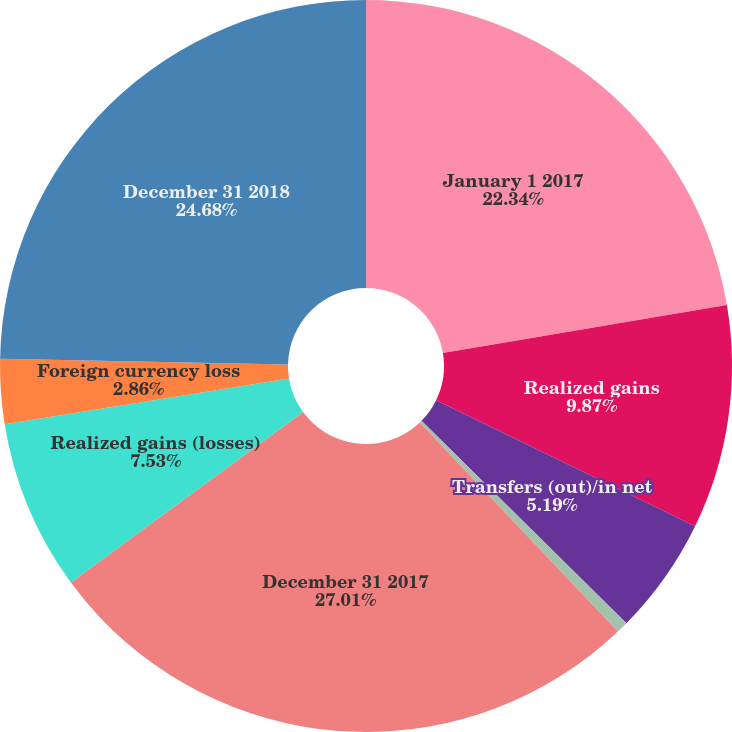<chart> <loc_0><loc_0><loc_500><loc_500><pie_chart><fcel>January 1 2017<fcel>Realized gains<fcel>Transfers (out)/in net<fcel>Foreign currency losses<fcel>December 31 2017<fcel>Realized gains (losses)<fcel>Foreign currency loss<fcel>December 31 2018<nl><fcel>22.34%<fcel>9.87%<fcel>5.19%<fcel>0.52%<fcel>27.01%<fcel>7.53%<fcel>2.86%<fcel>24.68%<nl></chart> 